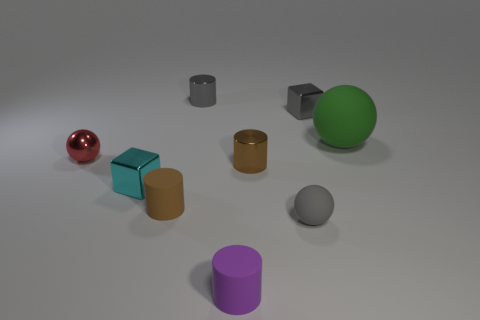What can you infer about the shapes present in the image? The image consists of a variety of geometric shapes including spheres, cylinders, and cuboids. Their presence in different sizes and colors could imply a study in shape and form, perhaps for an artistic purpose or to illustrate a concept in geometry. Is there any pattern to the arrangement of these shapes? While there isn't a strict pattern, there is a balanced distribution of shapes across the image, creating a sense of organized randomness. This might be intentional to attract interest without suggesting any particular order or hierarchy among the shapes. 